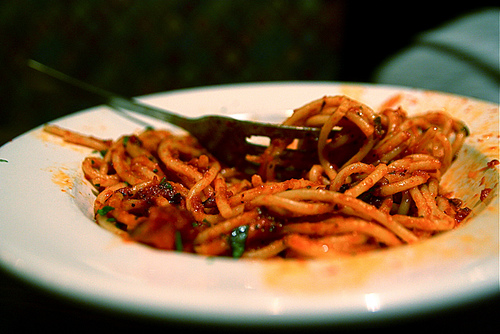<image>
Is the plate on the noodles? No. The plate is not positioned on the noodles. They may be near each other, but the plate is not supported by or resting on top of the noodles. 